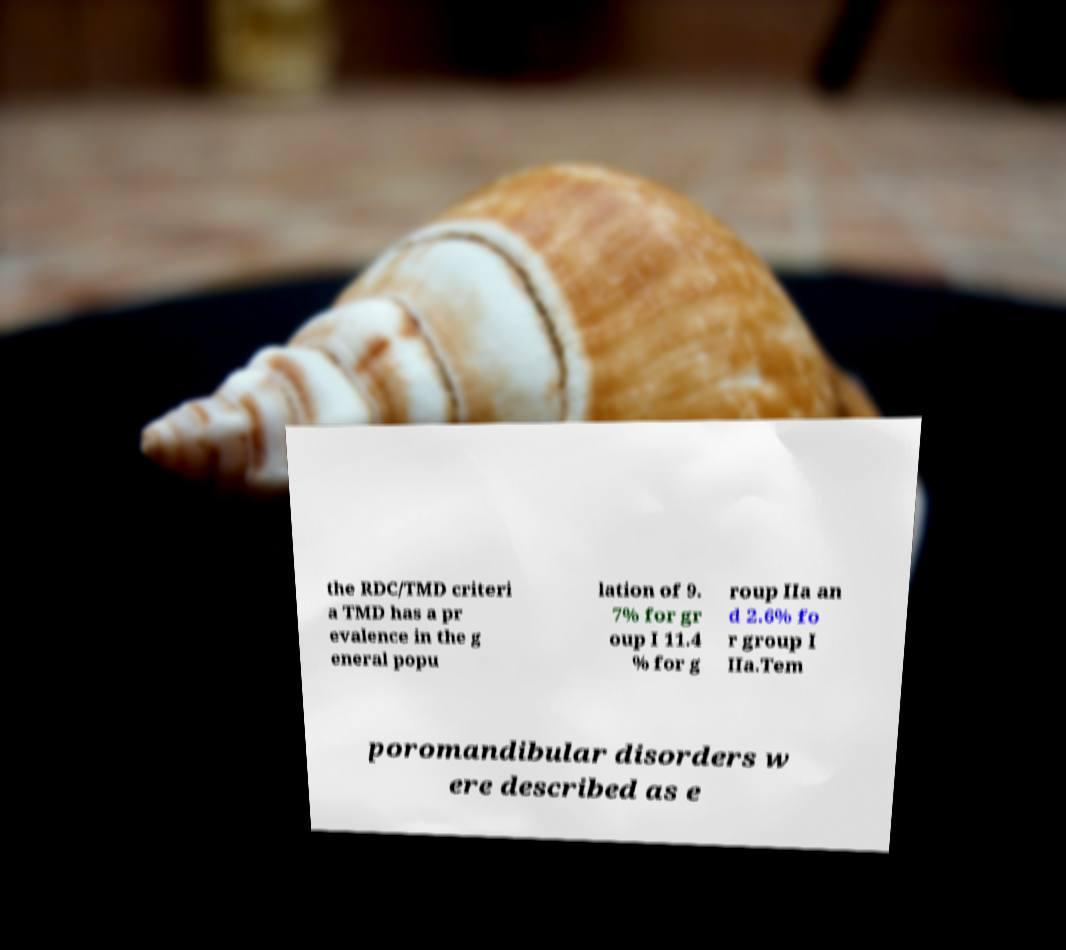For documentation purposes, I need the text within this image transcribed. Could you provide that? the RDC/TMD criteri a TMD has a pr evalence in the g eneral popu lation of 9. 7% for gr oup I 11.4 % for g roup IIa an d 2.6% fo r group I IIa.Tem poromandibular disorders w ere described as e 